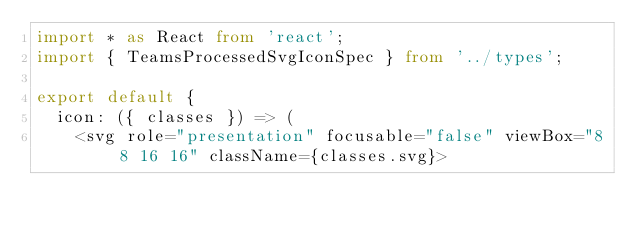Convert code to text. <code><loc_0><loc_0><loc_500><loc_500><_TypeScript_>import * as React from 'react';
import { TeamsProcessedSvgIconSpec } from '../types';

export default {
  icon: ({ classes }) => (
    <svg role="presentation" focusable="false" viewBox="8 8 16 16" className={classes.svg}></code> 